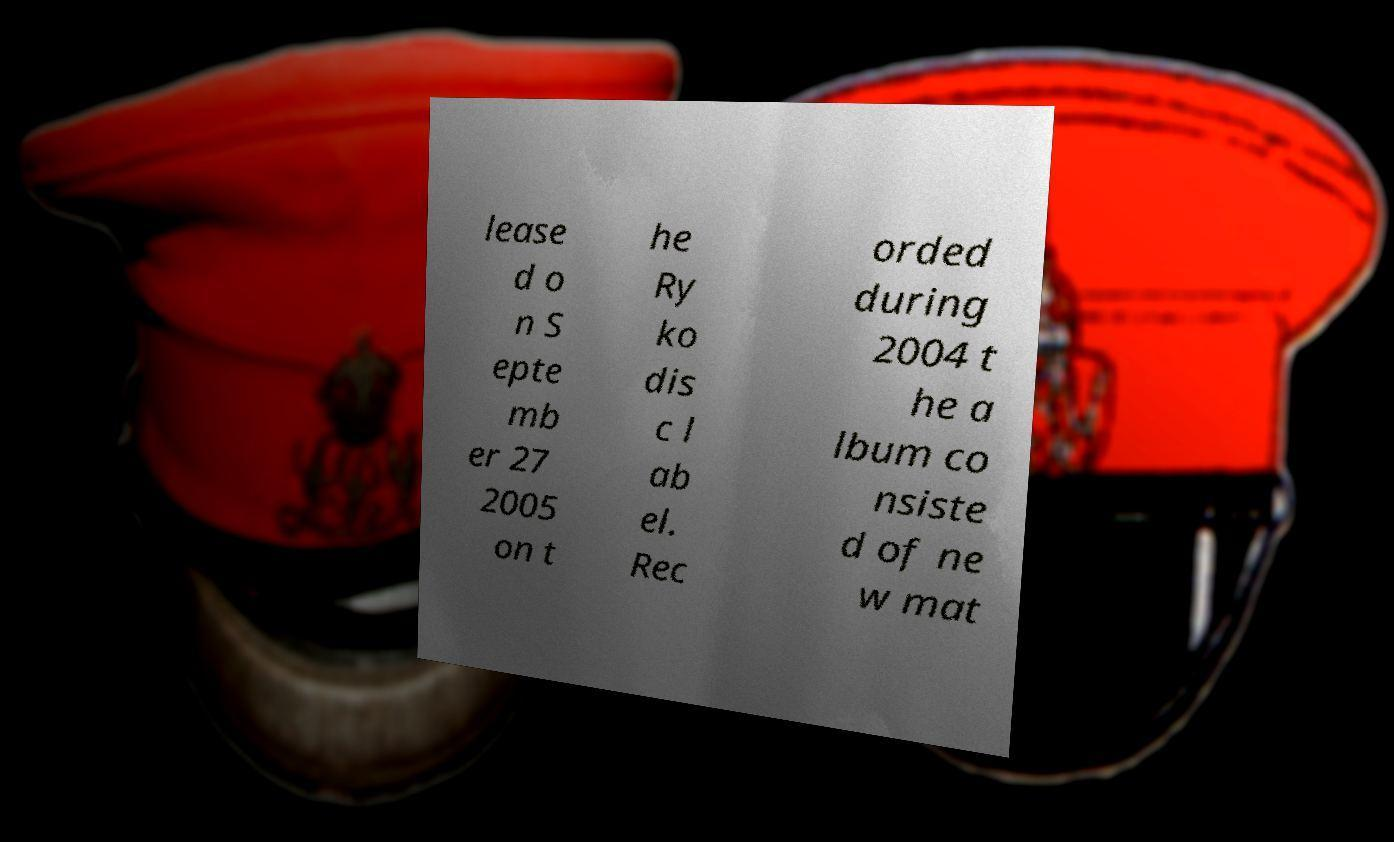Please read and relay the text visible in this image. What does it say? lease d o n S epte mb er 27 2005 on t he Ry ko dis c l ab el. Rec orded during 2004 t he a lbum co nsiste d of ne w mat 